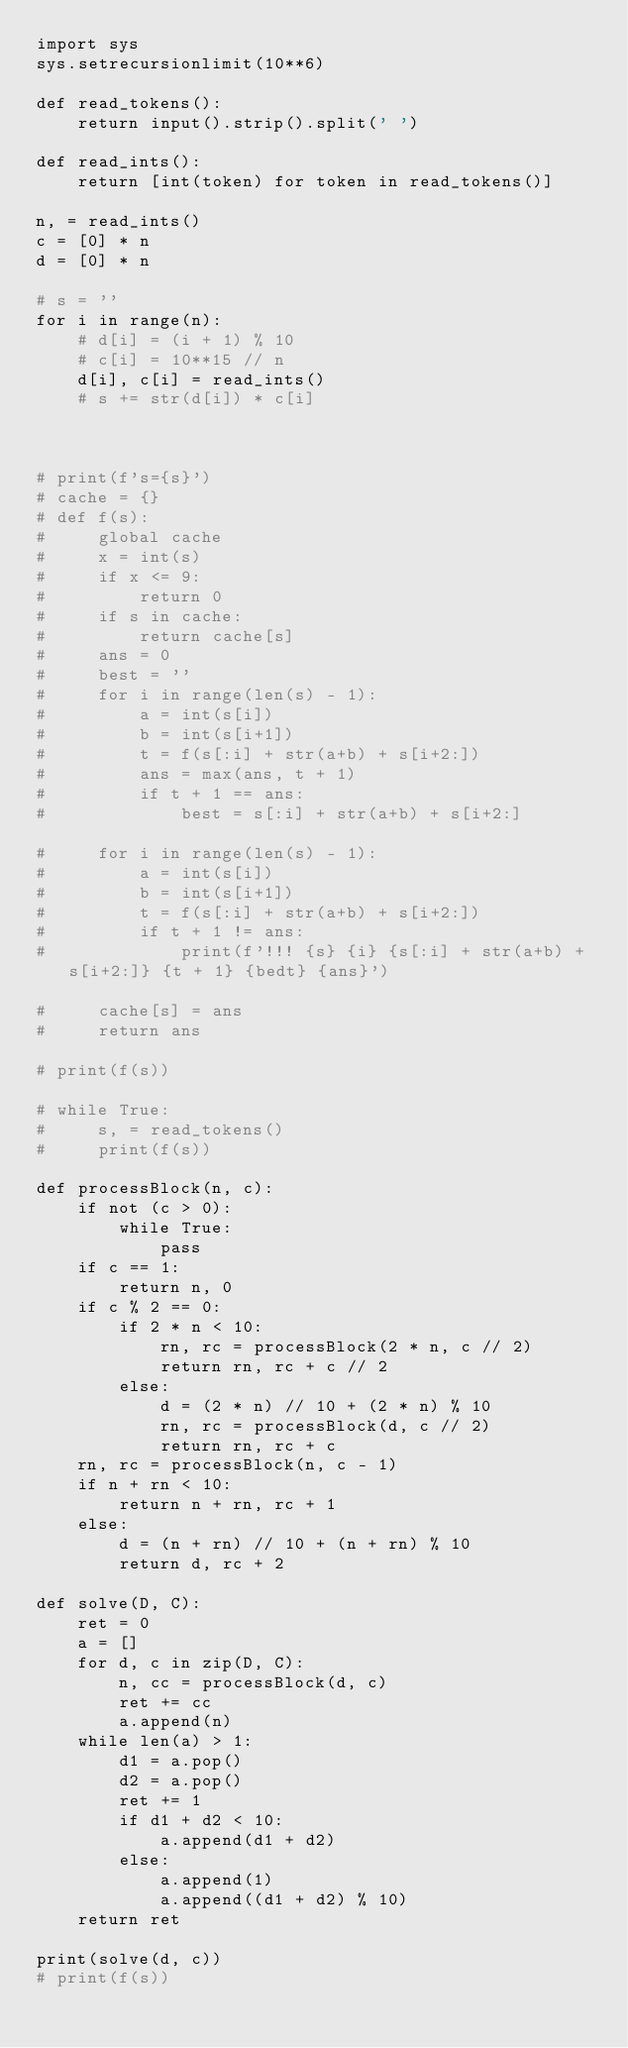Convert code to text. <code><loc_0><loc_0><loc_500><loc_500><_Python_>import sys
sys.setrecursionlimit(10**6)

def read_tokens():
    return input().strip().split(' ')

def read_ints():
    return [int(token) for token in read_tokens()]

n, = read_ints()
c = [0] * n
d = [0] * n

# s = ''
for i in range(n):
    # d[i] = (i + 1) % 10
    # c[i] = 10**15 // n
    d[i], c[i] = read_ints()
    # s += str(d[i]) * c[i]



# print(f's={s}')
# cache = {}
# def f(s):
#     global cache
#     x = int(s)
#     if x <= 9:
#         return 0
#     if s in cache:
#         return cache[s]
#     ans = 0
#     best = ''
#     for i in range(len(s) - 1):
#         a = int(s[i])
#         b = int(s[i+1])
#         t = f(s[:i] + str(a+b) + s[i+2:])
#         ans = max(ans, t + 1)
#         if t + 1 == ans:
#             best = s[:i] + str(a+b) + s[i+2:]

#     for i in range(len(s) - 1):
#         a = int(s[i])
#         b = int(s[i+1])
#         t = f(s[:i] + str(a+b) + s[i+2:])
#         if t + 1 != ans:
#             print(f'!!! {s} {i} {s[:i] + str(a+b) + s[i+2:]} {t + 1} {bedt} {ans}')

#     cache[s] = ans
#     return ans

# print(f(s))

# while True:
#     s, = read_tokens()
#     print(f(s))

def processBlock(n, c):
    if not (c > 0):
        while True:
            pass
    if c == 1:
        return n, 0
    if c % 2 == 0:
        if 2 * n < 10:
            rn, rc = processBlock(2 * n, c // 2)
            return rn, rc + c // 2
        else:
            d = (2 * n) // 10 + (2 * n) % 10
            rn, rc = processBlock(d, c // 2)
            return rn, rc + c
    rn, rc = processBlock(n, c - 1)
    if n + rn < 10:
        return n + rn, rc + 1
    else:
        d = (n + rn) // 10 + (n + rn) % 10
        return d, rc + 2

def solve(D, C):
    ret = 0
    a = []
    for d, c in zip(D, C):
        n, cc = processBlock(d, c)
        ret += cc
        a.append(n)
    while len(a) > 1:
        d1 = a.pop()
        d2 = a.pop()
        ret += 1
        if d1 + d2 < 10:
            a.append(d1 + d2)
        else:
            a.append(1)
            a.append((d1 + d2) % 10)
    return ret

print(solve(d, c))
# print(f(s))</code> 